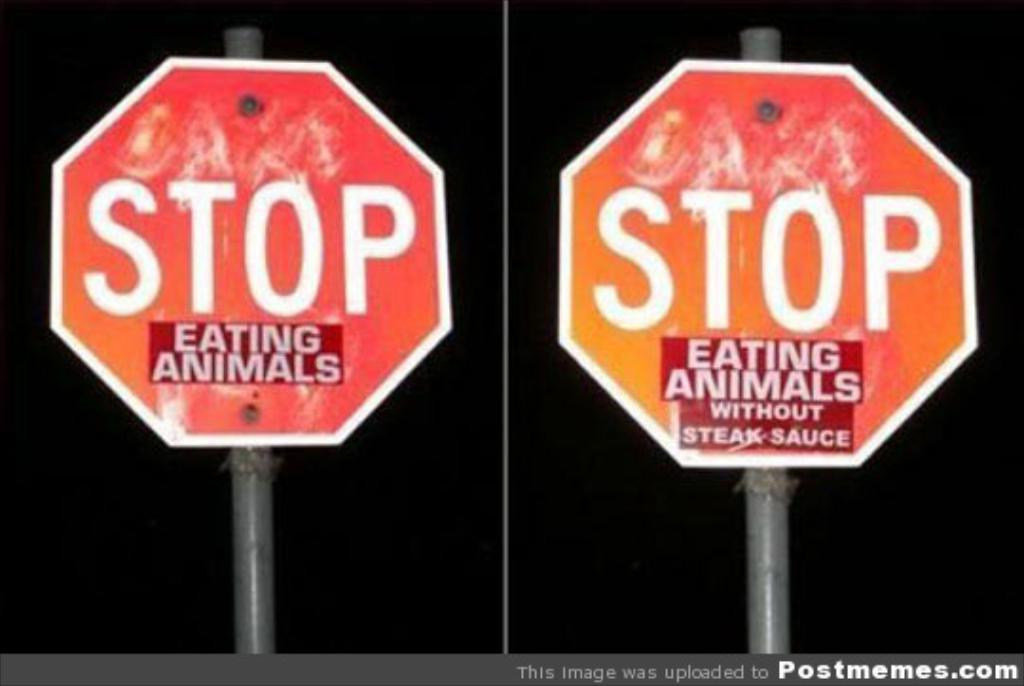<image>
Summarize the visual content of the image. A stop sign with a sticker sayin Eating Animals Without Steak Sauce. 